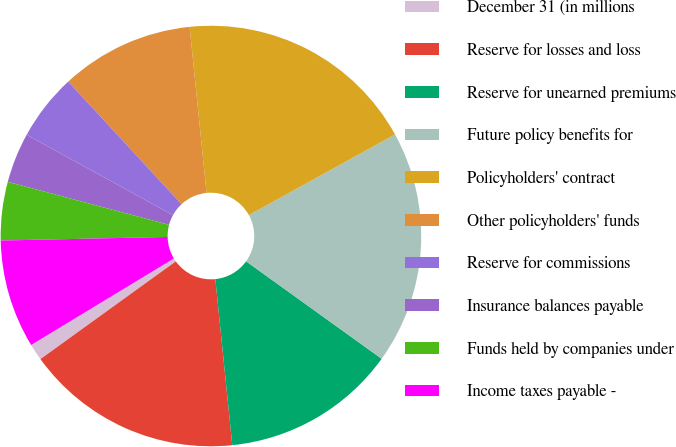Convert chart. <chart><loc_0><loc_0><loc_500><loc_500><pie_chart><fcel>December 31 (in millions<fcel>Reserve for losses and loss<fcel>Reserve for unearned premiums<fcel>Future policy benefits for<fcel>Policyholders' contract<fcel>Other policyholders' funds<fcel>Reserve for commissions<fcel>Insurance balances payable<fcel>Funds held by companies under<fcel>Income taxes payable -<nl><fcel>1.28%<fcel>16.67%<fcel>13.46%<fcel>17.95%<fcel>18.59%<fcel>10.26%<fcel>5.13%<fcel>3.85%<fcel>4.49%<fcel>8.33%<nl></chart> 